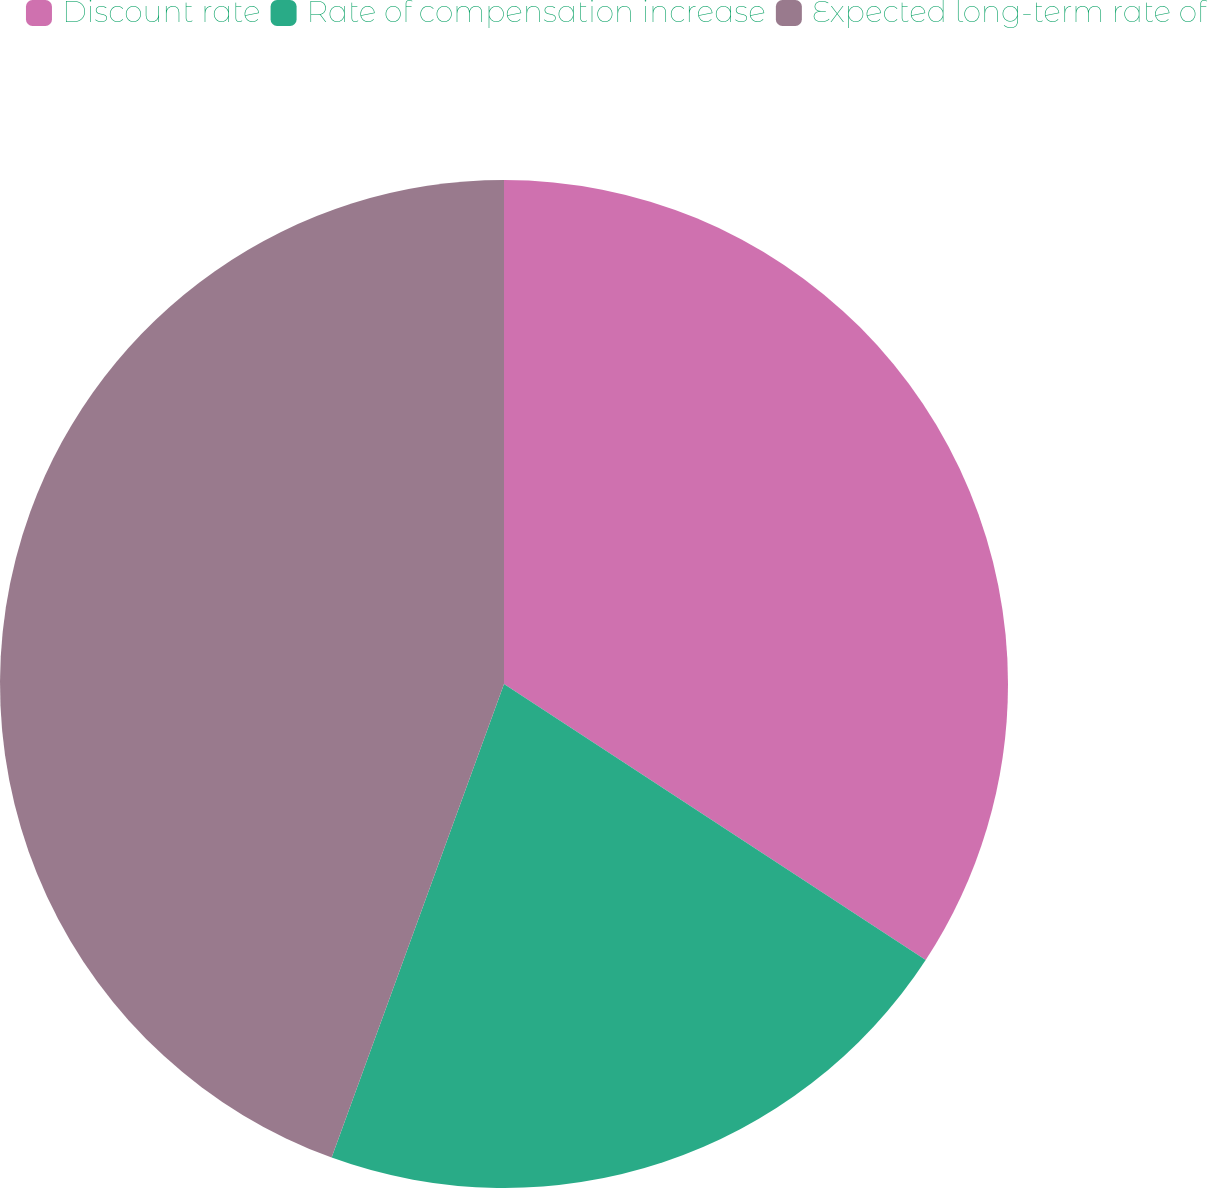Convert chart. <chart><loc_0><loc_0><loc_500><loc_500><pie_chart><fcel>Discount rate<fcel>Rate of compensation increase<fcel>Expected long-term rate of<nl><fcel>34.22%<fcel>21.33%<fcel>44.44%<nl></chart> 